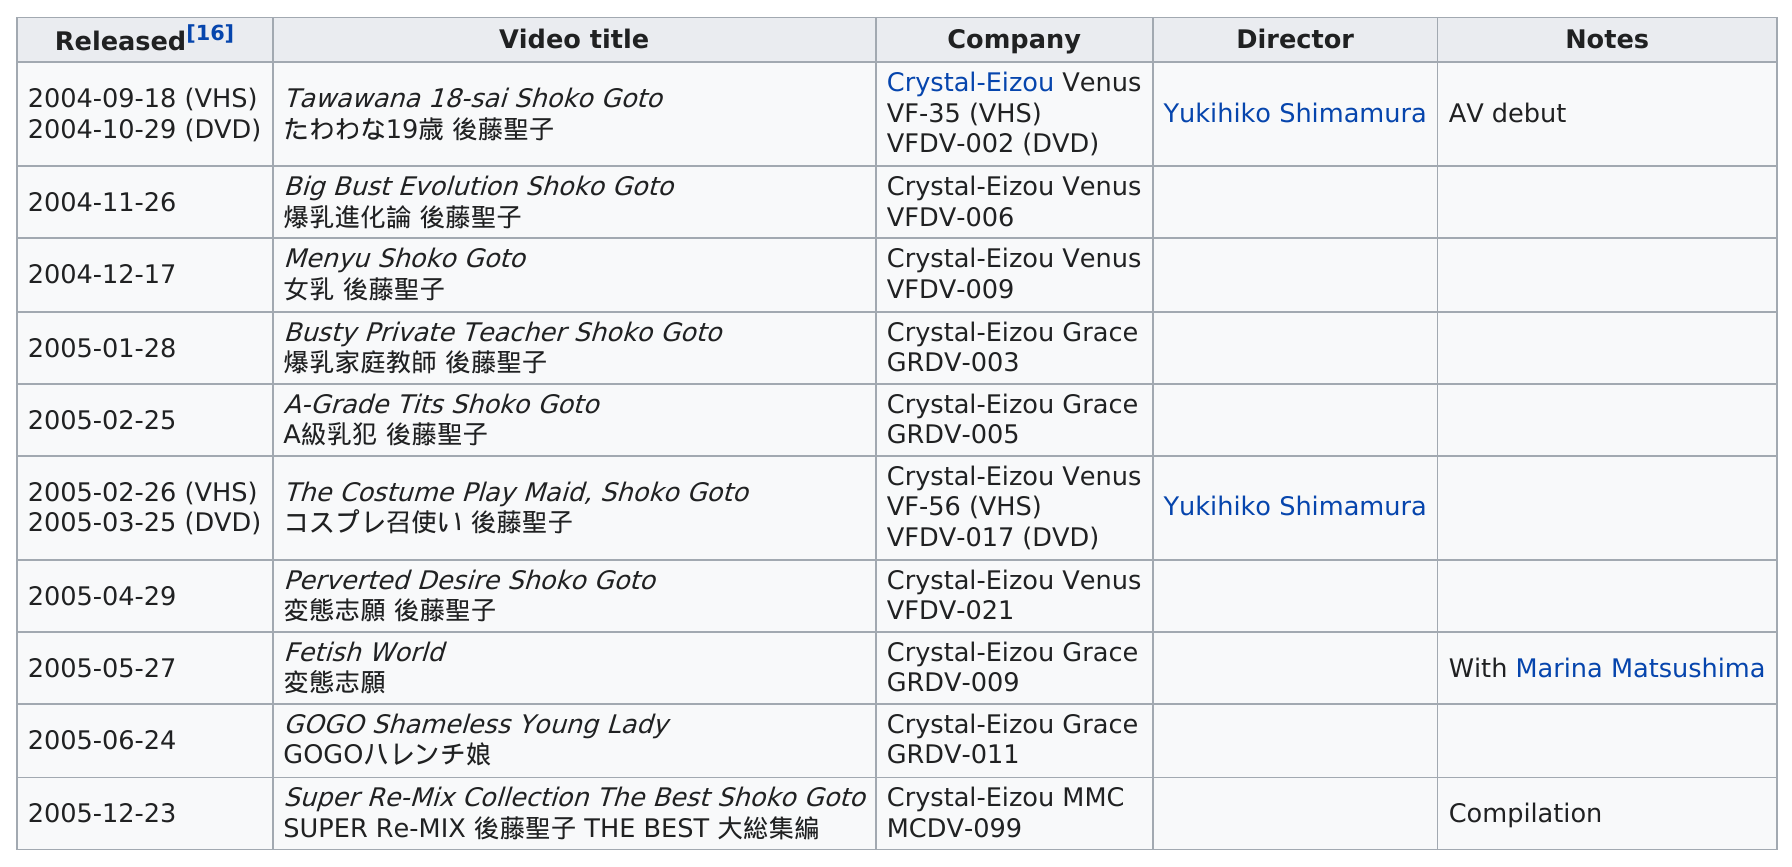Indicate a few pertinent items in this graphic. There was a 28-day difference between the release of "Perverted Desire: Shoko Goto" and "Fetish World. The last film that Shoko Goto appeared in was "Super Re-Mix Collection The Best Shoko Goto SUPER Re-MIX 後藤聖子 THE BEST 大総集編" in 2005. As of February 24, 2006, no prisoners were released. The first pornographic film listed on the table is Tawawana 18-sai Shoko Goto, who is 19 years old and is named Saint Goto. She has released a total of 10 videos. 